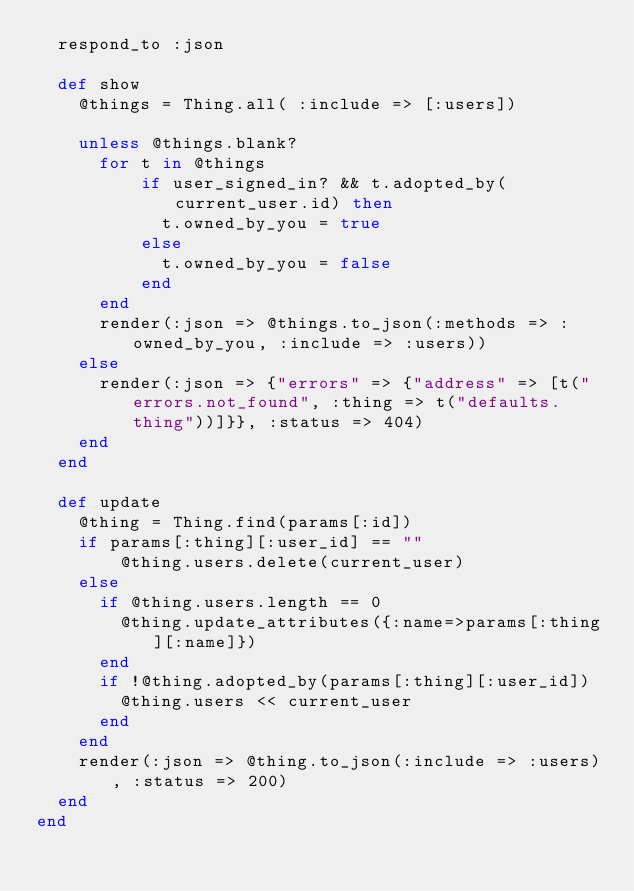<code> <loc_0><loc_0><loc_500><loc_500><_Ruby_>  respond_to :json

  def show
    @things = Thing.all( :include => [:users])

    unless @things.blank?
      for t in @things
          if user_signed_in? && t.adopted_by(current_user.id) then
            t.owned_by_you = true
          else
            t.owned_by_you = false
          end
      end
      render(:json => @things.to_json(:methods => :owned_by_you, :include => :users))
    else
      render(:json => {"errors" => {"address" => [t("errors.not_found", :thing => t("defaults.thing"))]}}, :status => 404)
    end
  end

  def update
    @thing = Thing.find(params[:id])
    if params[:thing][:user_id] == ""
        @thing.users.delete(current_user)
    else
      if @thing.users.length == 0
        @thing.update_attributes({:name=>params[:thing][:name]})
      end
      if !@thing.adopted_by(params[:thing][:user_id])
        @thing.users << current_user
      end
    end
    render(:json => @thing.to_json(:include => :users), :status => 200)
  end
end
</code> 